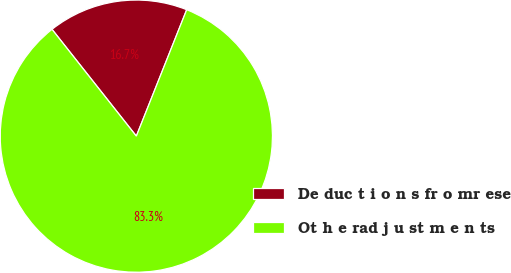<chart> <loc_0><loc_0><loc_500><loc_500><pie_chart><fcel>De duc t i o n s fr o mr ese<fcel>Ot h e rad j u st m e n ts<nl><fcel>16.67%<fcel>83.33%<nl></chart> 